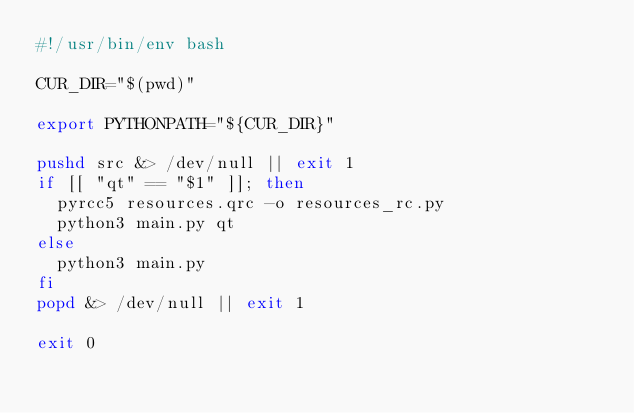<code> <loc_0><loc_0><loc_500><loc_500><_Bash_>#!/usr/bin/env bash

CUR_DIR="$(pwd)"

export PYTHONPATH="${CUR_DIR}"

pushd src &> /dev/null || exit 1
if [[ "qt" == "$1" ]]; then
  pyrcc5 resources.qrc -o resources_rc.py
  python3 main.py qt
else
  python3 main.py
fi
popd &> /dev/null || exit 1

exit 0</code> 